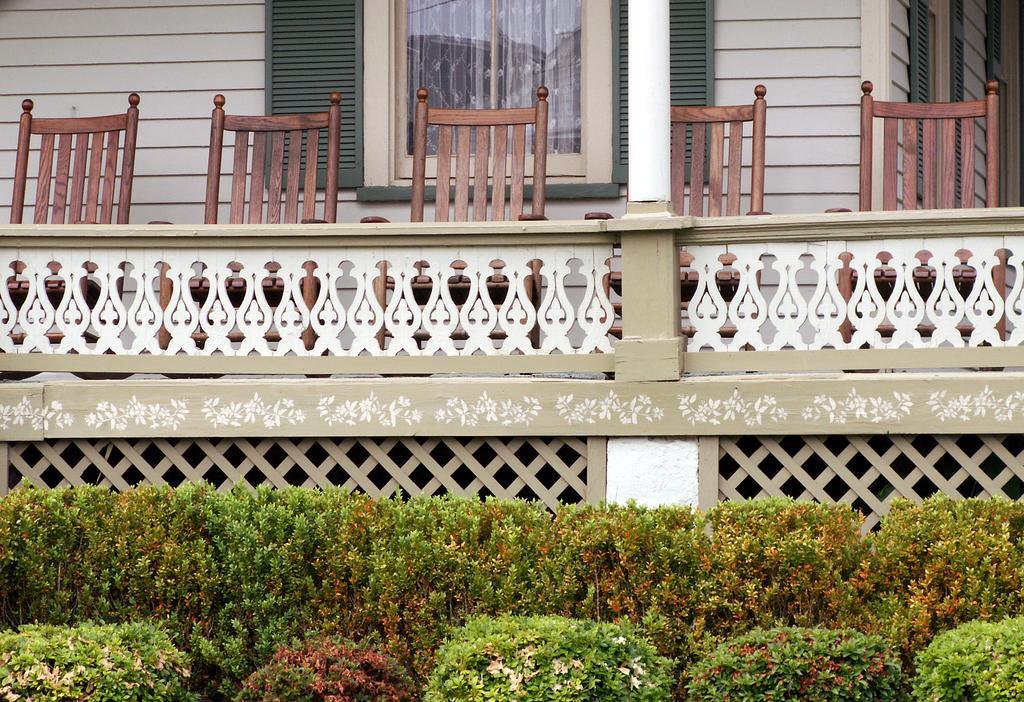In one or two sentences, can you explain what this image depicts? In this image I can see few chairs in brown color, in front the building is in white color. I can also see a window and few plants in green color. 